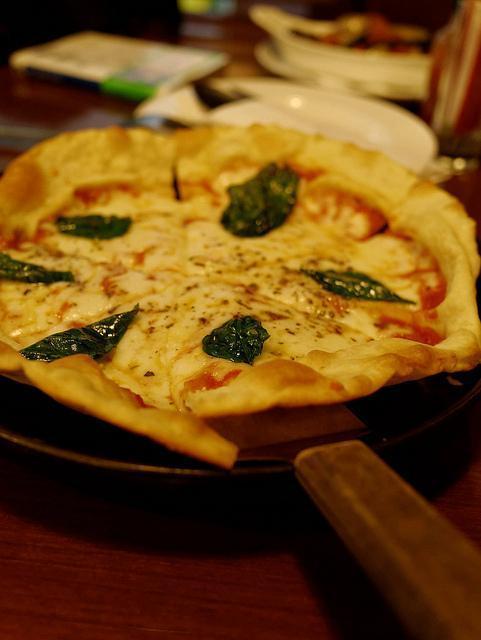How many vegetables are on the pizza?
Give a very brief answer. 1. How many chairs don't have a dog on them?
Give a very brief answer. 0. 